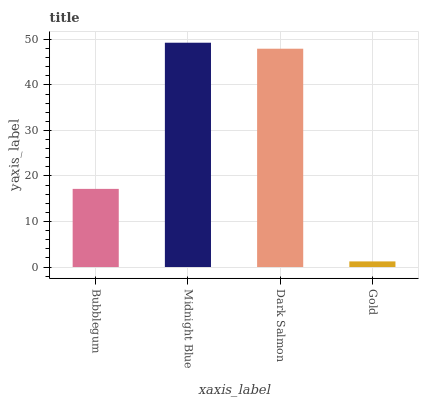Is Gold the minimum?
Answer yes or no. Yes. Is Midnight Blue the maximum?
Answer yes or no. Yes. Is Dark Salmon the minimum?
Answer yes or no. No. Is Dark Salmon the maximum?
Answer yes or no. No. Is Midnight Blue greater than Dark Salmon?
Answer yes or no. Yes. Is Dark Salmon less than Midnight Blue?
Answer yes or no. Yes. Is Dark Salmon greater than Midnight Blue?
Answer yes or no. No. Is Midnight Blue less than Dark Salmon?
Answer yes or no. No. Is Dark Salmon the high median?
Answer yes or no. Yes. Is Bubblegum the low median?
Answer yes or no. Yes. Is Gold the high median?
Answer yes or no. No. Is Midnight Blue the low median?
Answer yes or no. No. 